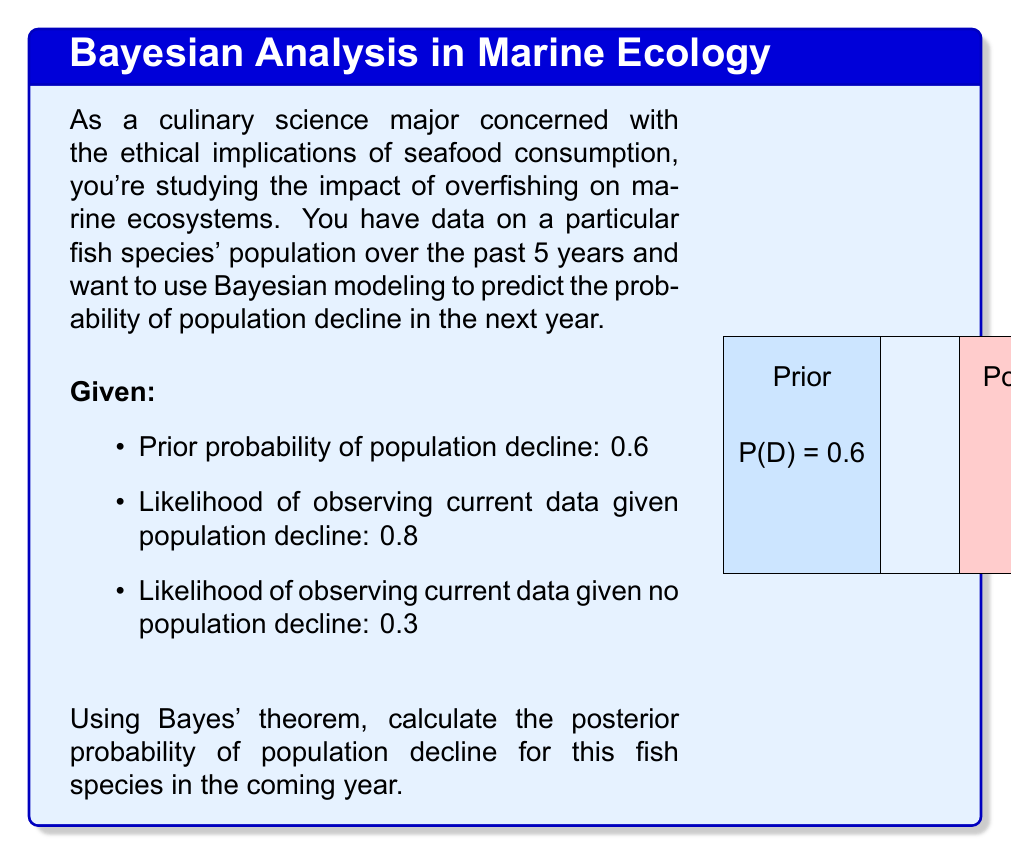Can you solve this math problem? Let's approach this step-by-step using Bayes' theorem:

1) Bayes' theorem is given by:

   $$P(A|B) = \frac{P(B|A) \cdot P(A)}{P(B)}$$

   Where:
   A is the event of population decline
   B is the observed data

2) We're given:
   $P(A)$ (prior probability of decline) = 0.6
   $P(B|A)$ (likelihood of data given decline) = 0.8
   $P(B|\neg A)$ (likelihood of data given no decline) = 0.3

3) We need to calculate $P(B)$ using the law of total probability:

   $$P(B) = P(B|A) \cdot P(A) + P(B|\neg A) \cdot P(\neg A)$$

4) Calculate $P(\neg A)$:
   $P(\neg A) = 1 - P(A) = 1 - 0.6 = 0.4$

5) Now calculate $P(B)$:
   $$P(B) = 0.8 \cdot 0.6 + 0.3 \cdot 0.4 = 0.48 + 0.12 = 0.6$$

6) Apply Bayes' theorem:

   $$P(A|B) = \frac{P(B|A) \cdot P(A)}{P(B)} = \frac{0.8 \cdot 0.6}{0.6} = 0.8$$

Therefore, the posterior probability of population decline is 0.8 or 80%.
Answer: 0.8 